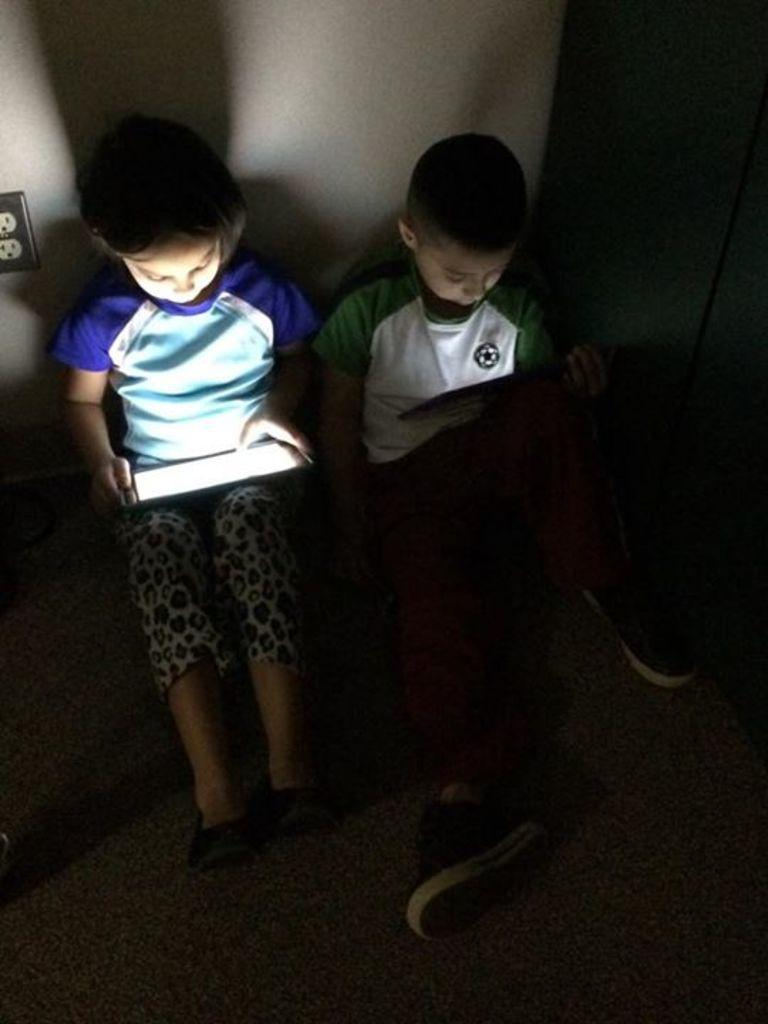How many children are present in the image? There are two children in the image. What are the children holding in their hands? The children are holding tabs in their hands. What can be seen in the background of the image? There is a wall visible in the background of the image. What type of base is supporting the children in the image? There is no base visible in the image, as the children appear to be standing on the ground. 